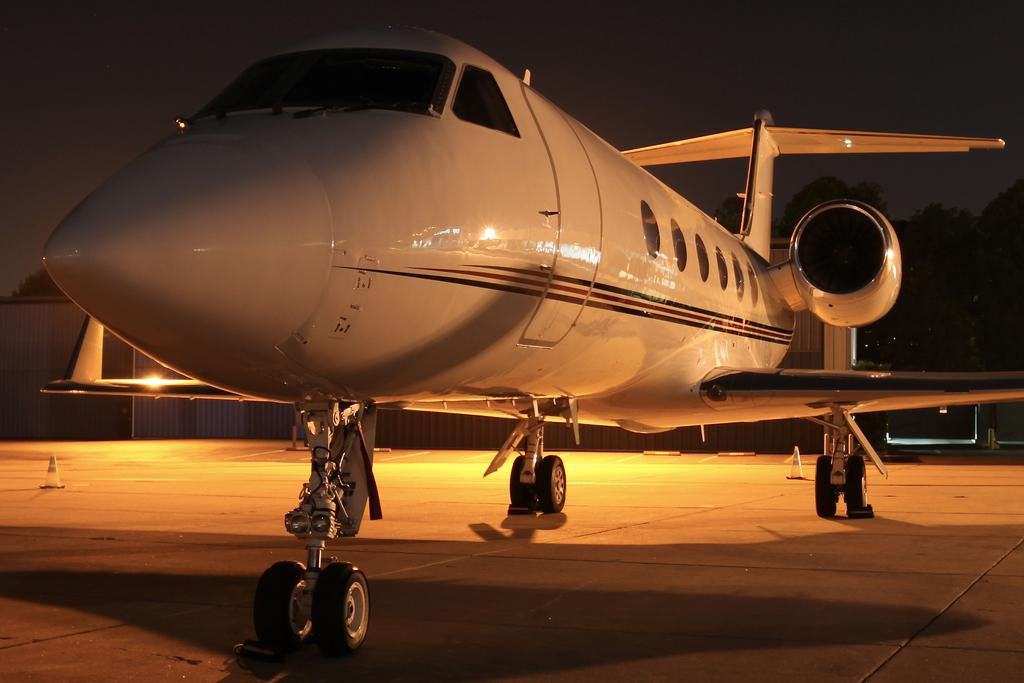What is the color of the aircraft in the image? The aircraft in the image is white. What can be seen in the background of the image? There are trees in the background of the image. What type of flag is being waved by the aircraft in the image? There is no flag being waved by the aircraft in the image. How does the aircraft rest on the ground in the image? The aircraft is in the air and not resting on the ground in the image. 